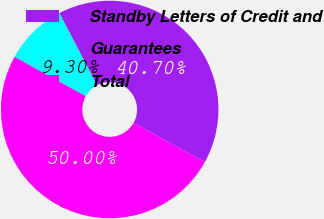Convert chart to OTSL. <chart><loc_0><loc_0><loc_500><loc_500><pie_chart><fcel>Standby Letters of Credit and<fcel>Guarantees<fcel>Total<nl><fcel>40.7%<fcel>9.3%<fcel>50.0%<nl></chart> 